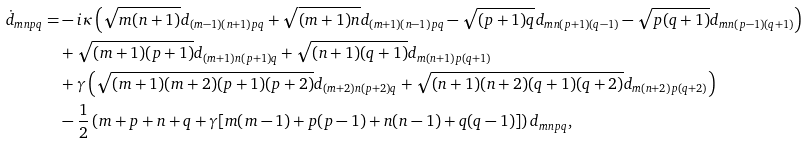<formula> <loc_0><loc_0><loc_500><loc_500>\dot { d } _ { m n p q } = & - i \kappa \left ( \sqrt { m ( n + 1 ) } d _ { ( m - 1 ) ( n + 1 ) p q } + \sqrt { ( m + 1 ) n } d _ { ( m + 1 ) ( n - 1 ) p q } - \sqrt { ( p + 1 ) q } d _ { m n ( p + 1 ) ( q - 1 ) } - \sqrt { p ( q + 1 ) } d _ { m n ( p - 1 ) ( q + 1 ) } \right ) \\ & + \sqrt { ( m + 1 ) ( p + 1 ) } d _ { ( m + 1 ) n ( p + 1 ) q } + \sqrt { ( n + 1 ) ( q + 1 ) } d _ { m ( n + 1 ) p ( q + 1 ) } \\ & + \gamma \left ( \sqrt { ( m + 1 ) ( m + 2 ) ( p + 1 ) ( p + 2 ) } d _ { ( m + 2 ) n ( p + 2 ) q } + \sqrt { ( n + 1 ) ( n + 2 ) ( q + 1 ) ( q + 2 ) } d _ { m ( n + 2 ) p ( q + 2 ) } \right ) \\ & - \frac { 1 } { 2 } \left ( m + p + n + q + \gamma [ m ( m - 1 ) + p ( p - 1 ) + n ( n - 1 ) + q ( q - 1 ) ] \right ) d _ { m n p q } ,</formula> 